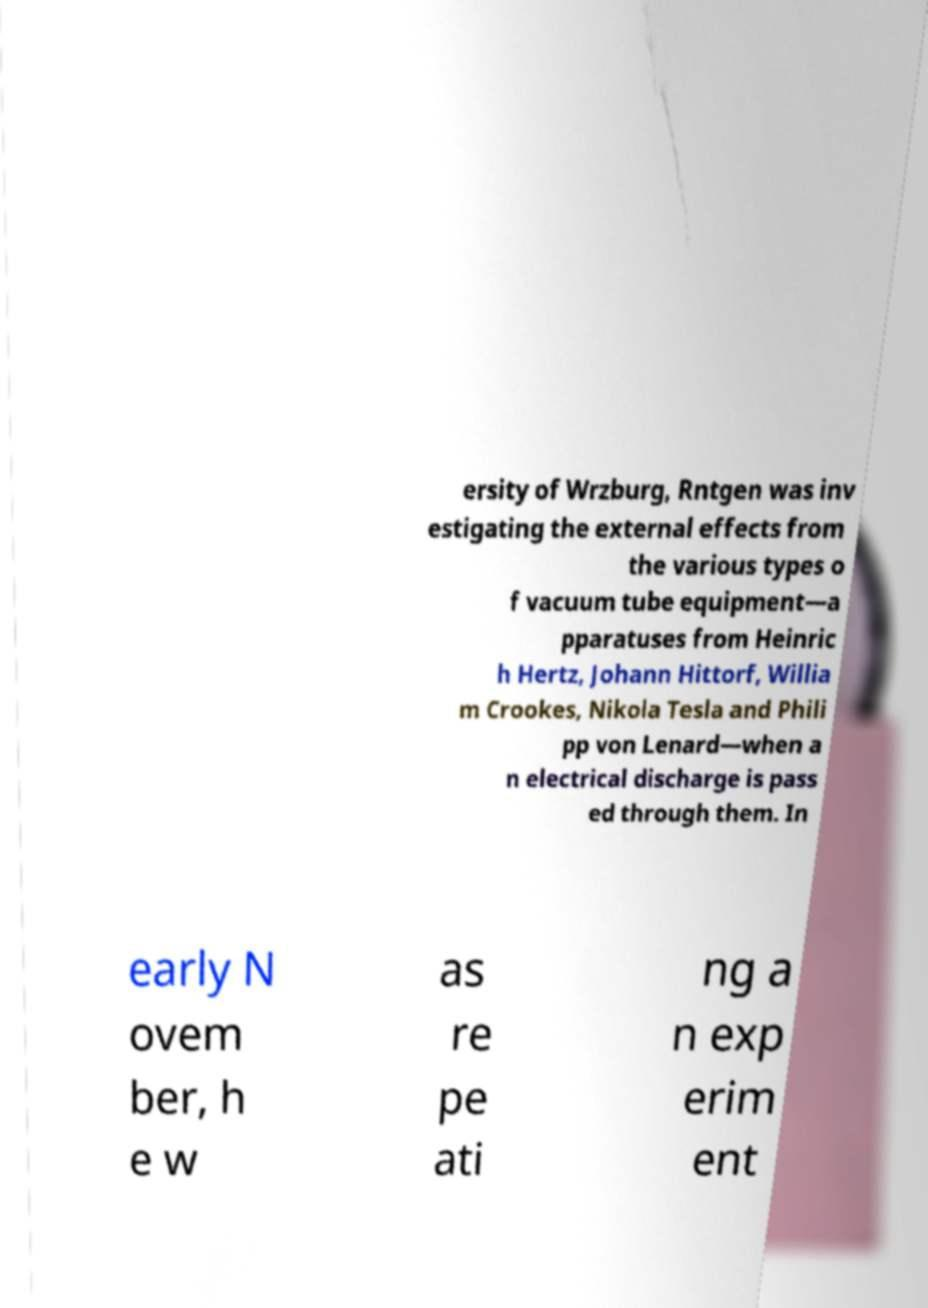Can you accurately transcribe the text from the provided image for me? ersity of Wrzburg, Rntgen was inv estigating the external effects from the various types o f vacuum tube equipment—a pparatuses from Heinric h Hertz, Johann Hittorf, Willia m Crookes, Nikola Tesla and Phili pp von Lenard—when a n electrical discharge is pass ed through them. In early N ovem ber, h e w as re pe ati ng a n exp erim ent 